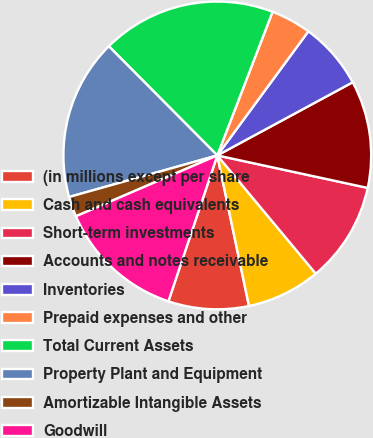Convert chart to OTSL. <chart><loc_0><loc_0><loc_500><loc_500><pie_chart><fcel>(in millions except per share<fcel>Cash and cash equivalents<fcel>Short-term investments<fcel>Accounts and notes receivable<fcel>Inventories<fcel>Prepaid expenses and other<fcel>Total Current Assets<fcel>Property Plant and Equipment<fcel>Amortizable Intangible Assets<fcel>Goodwill<nl><fcel>8.45%<fcel>7.75%<fcel>10.56%<fcel>11.27%<fcel>7.04%<fcel>4.23%<fcel>18.3%<fcel>16.9%<fcel>2.12%<fcel>13.38%<nl></chart> 